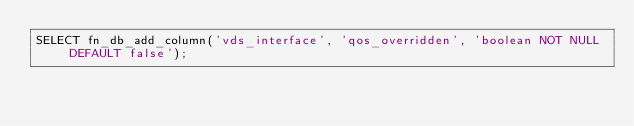Convert code to text. <code><loc_0><loc_0><loc_500><loc_500><_SQL_>SELECT fn_db_add_column('vds_interface', 'qos_overridden', 'boolean NOT NULL DEFAULT false');
</code> 